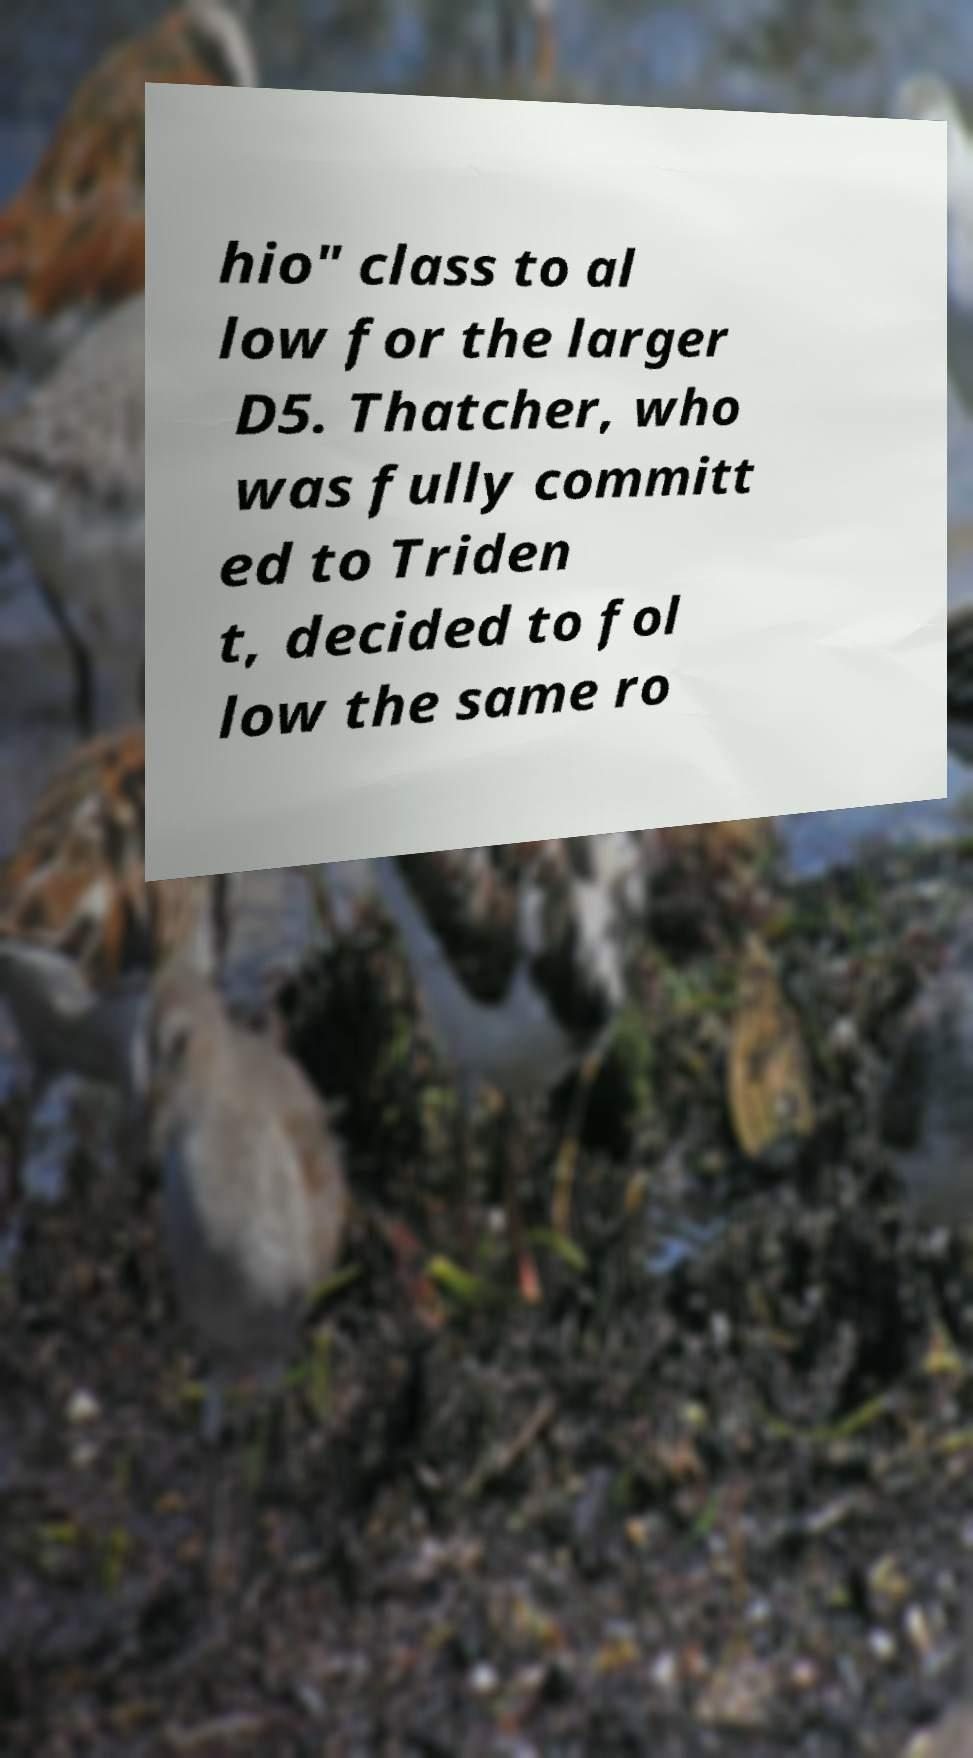Can you accurately transcribe the text from the provided image for me? hio" class to al low for the larger D5. Thatcher, who was fully committ ed to Triden t, decided to fol low the same ro 